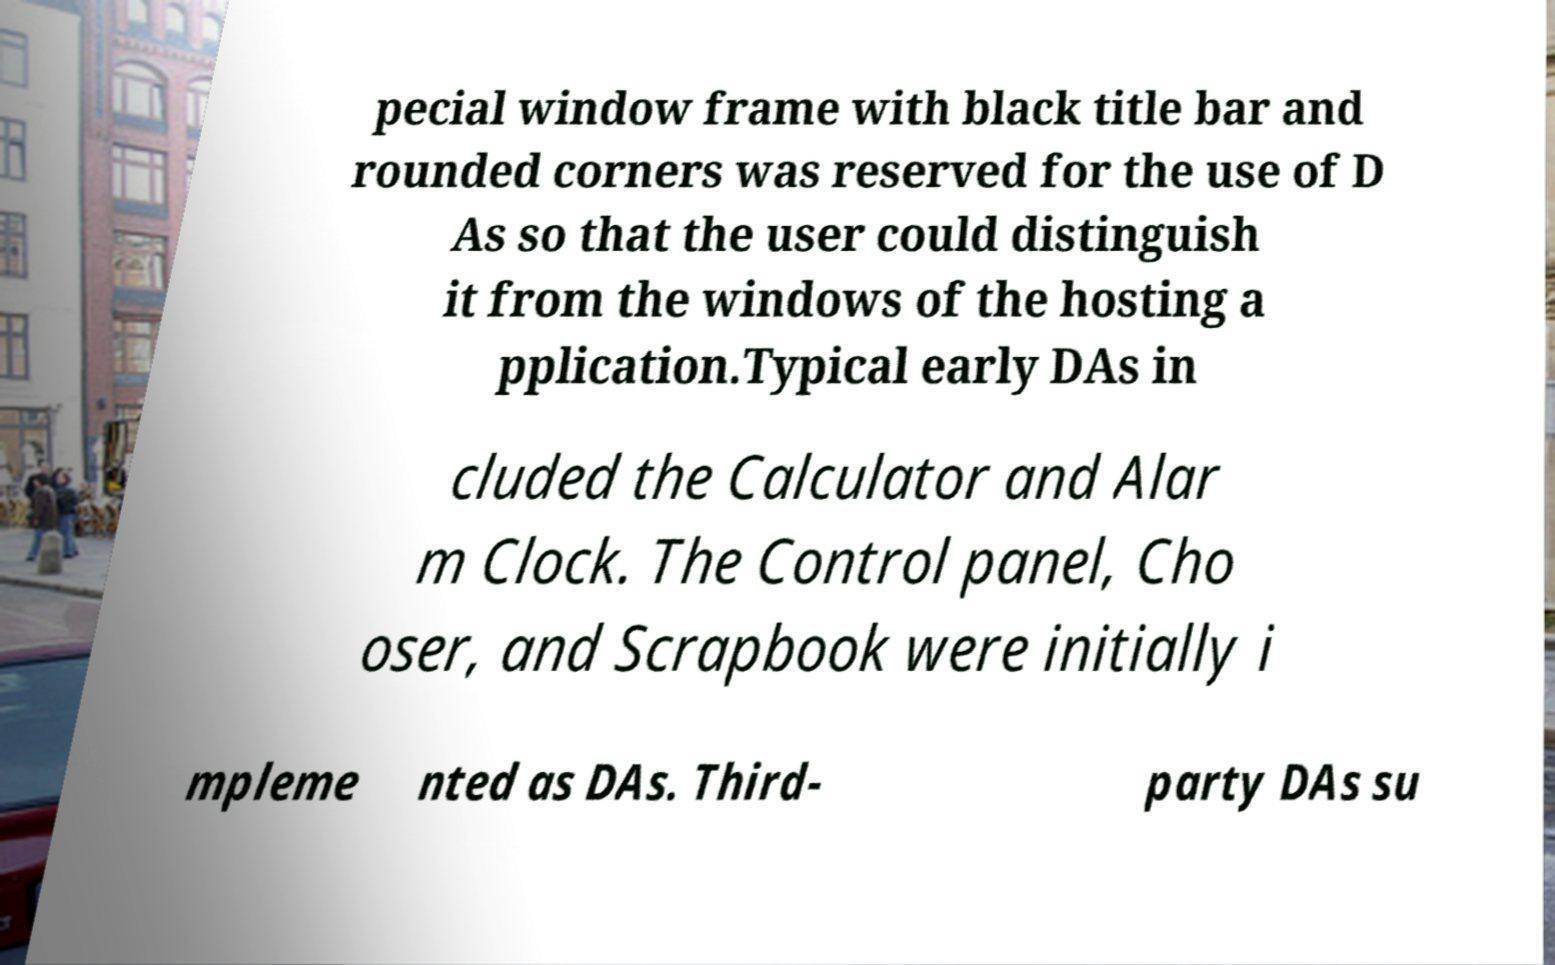For documentation purposes, I need the text within this image transcribed. Could you provide that? pecial window frame with black title bar and rounded corners was reserved for the use of D As so that the user could distinguish it from the windows of the hosting a pplication.Typical early DAs in cluded the Calculator and Alar m Clock. The Control panel, Cho oser, and Scrapbook were initially i mpleme nted as DAs. Third- party DAs su 